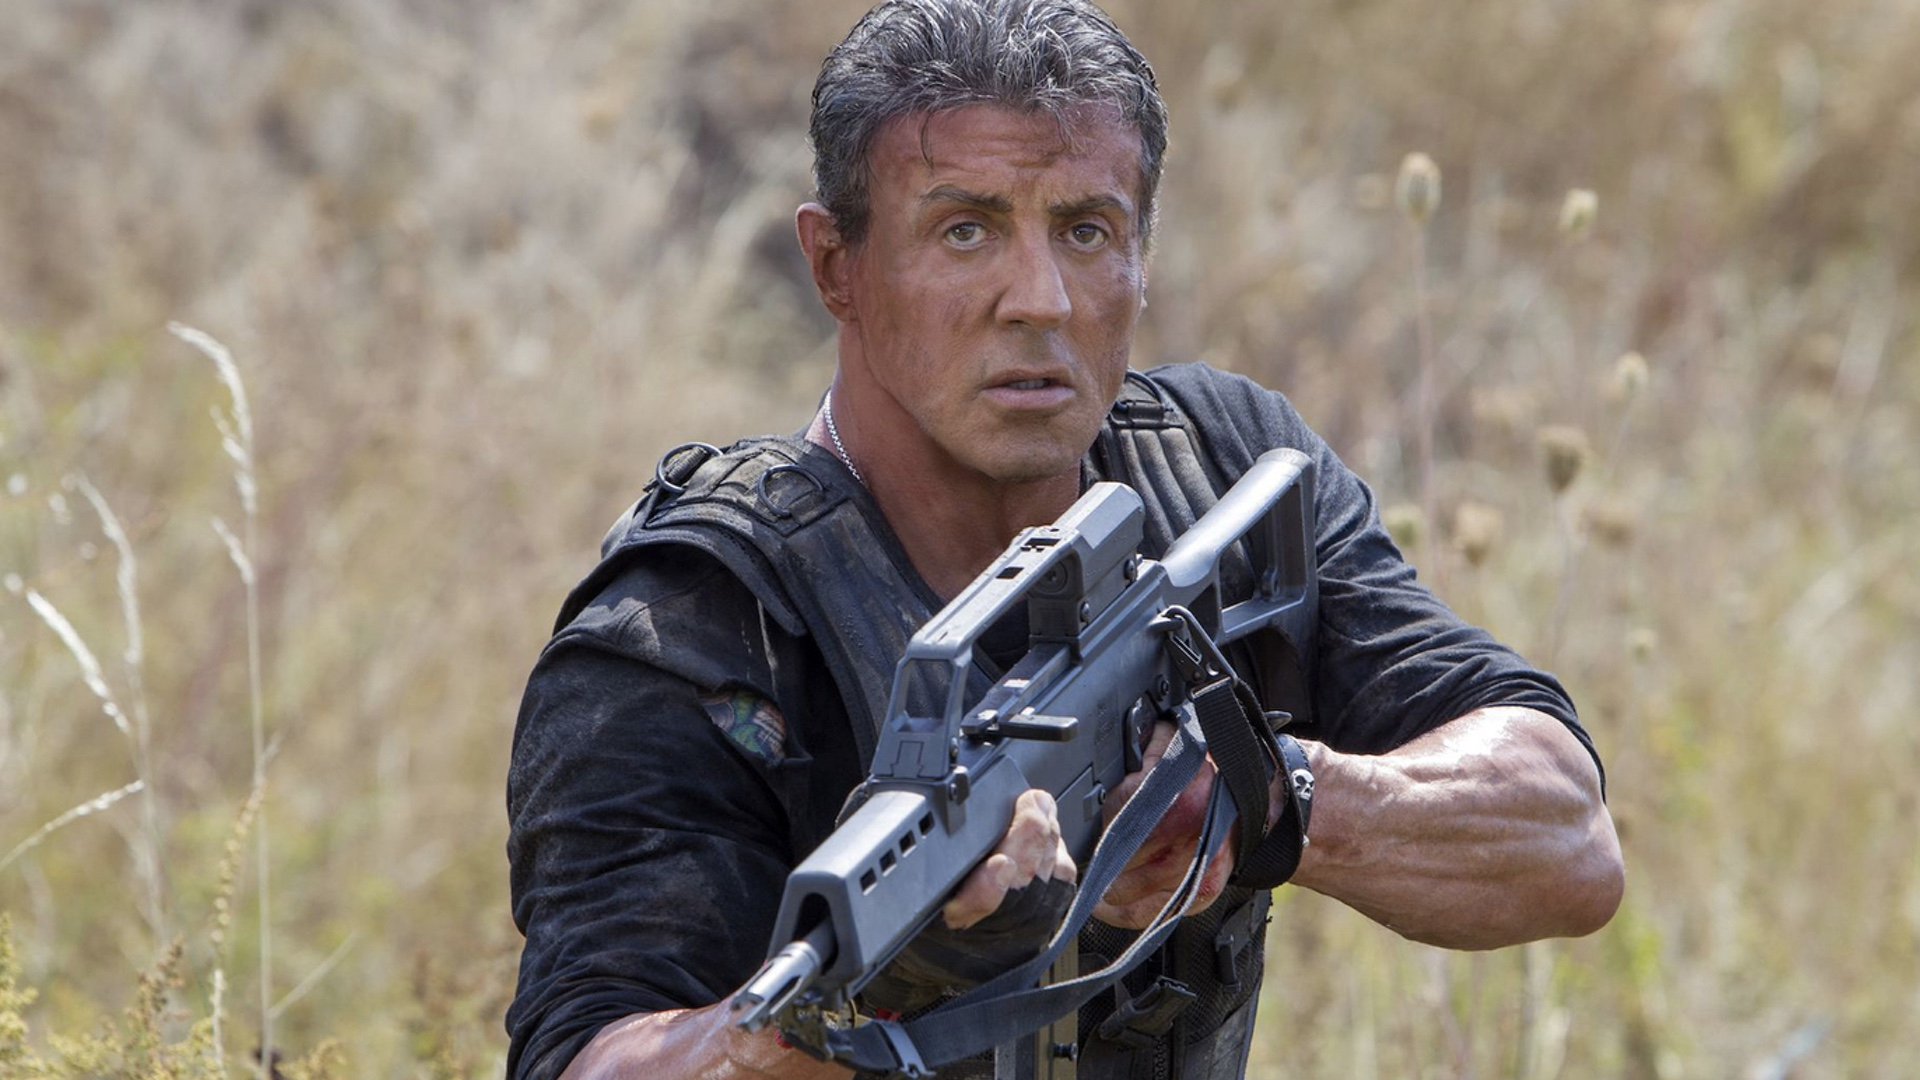If this scene were part of a storyline, what might be happening beforehand? Leading up to this scene, it's plausible that Rambo has been tracking or evading enemies through the wilderness. He might have uncovered some crucial information or encountered environmental obstacles that necessitate immediate action. This moment captures him at the brink of executing a critical tactical decision, with everything hanging in the balance. 